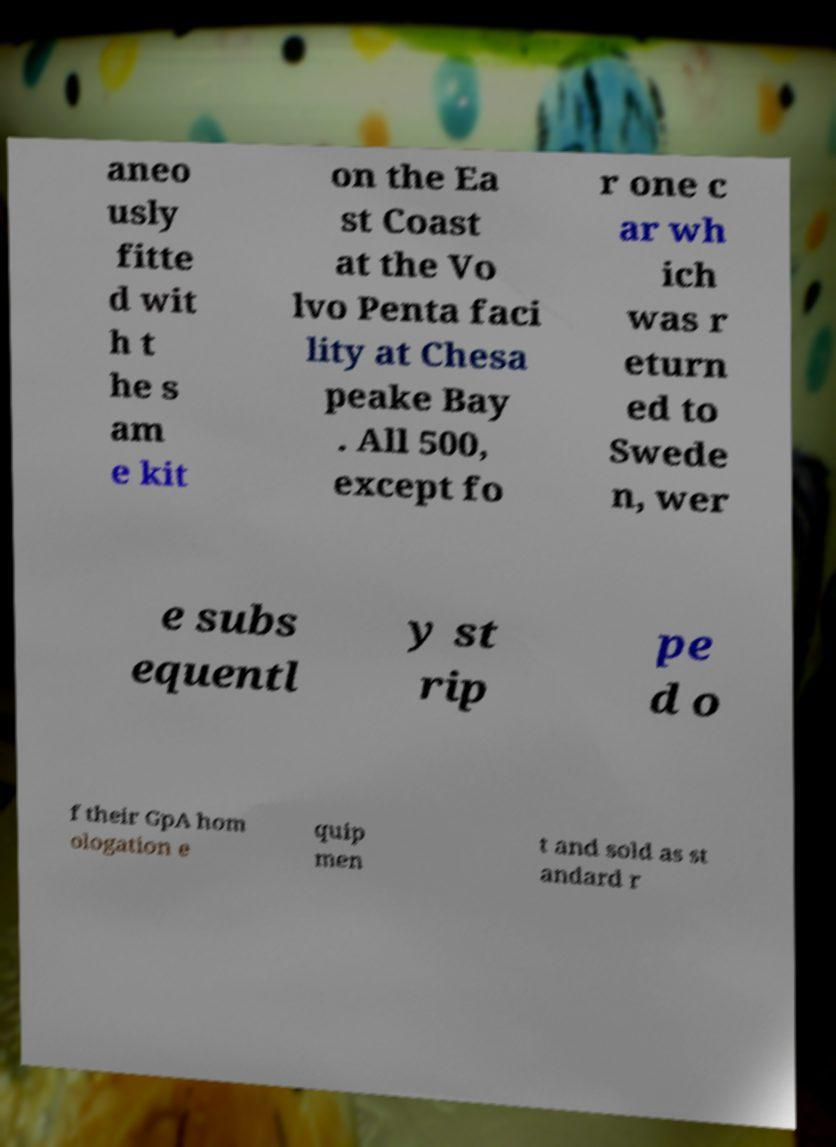Can you accurately transcribe the text from the provided image for me? aneo usly fitte d wit h t he s am e kit on the Ea st Coast at the Vo lvo Penta faci lity at Chesa peake Bay . All 500, except fo r one c ar wh ich was r eturn ed to Swede n, wer e subs equentl y st rip pe d o f their GpA hom ologation e quip men t and sold as st andard r 